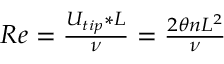<formula> <loc_0><loc_0><loc_500><loc_500>\begin{array} { r } { R e = \frac { U _ { t i p } * L } { \nu } = \frac { 2 \theta n L ^ { 2 } } { \nu } \, } \end{array}</formula> 